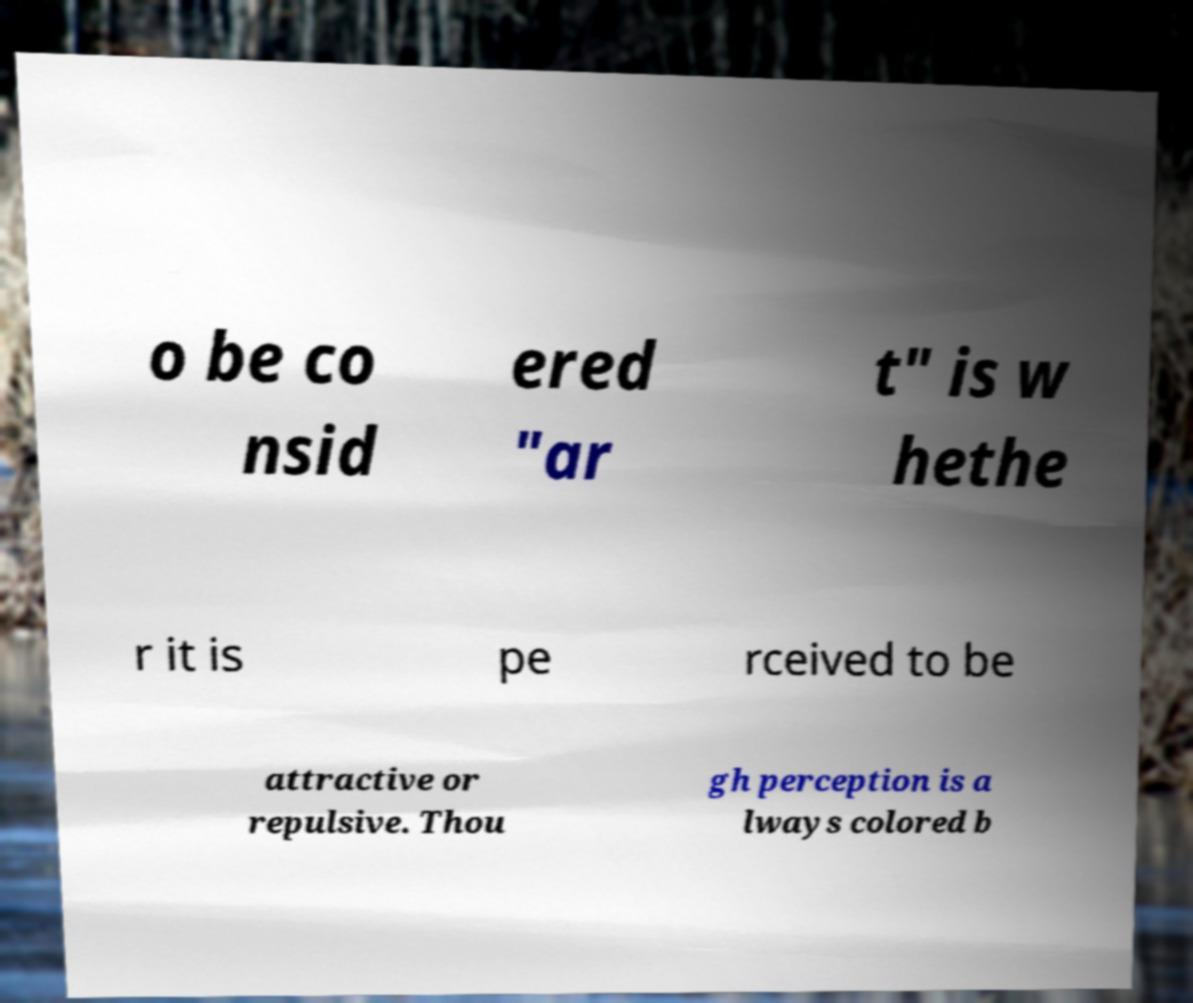Can you accurately transcribe the text from the provided image for me? o be co nsid ered "ar t" is w hethe r it is pe rceived to be attractive or repulsive. Thou gh perception is a lways colored b 